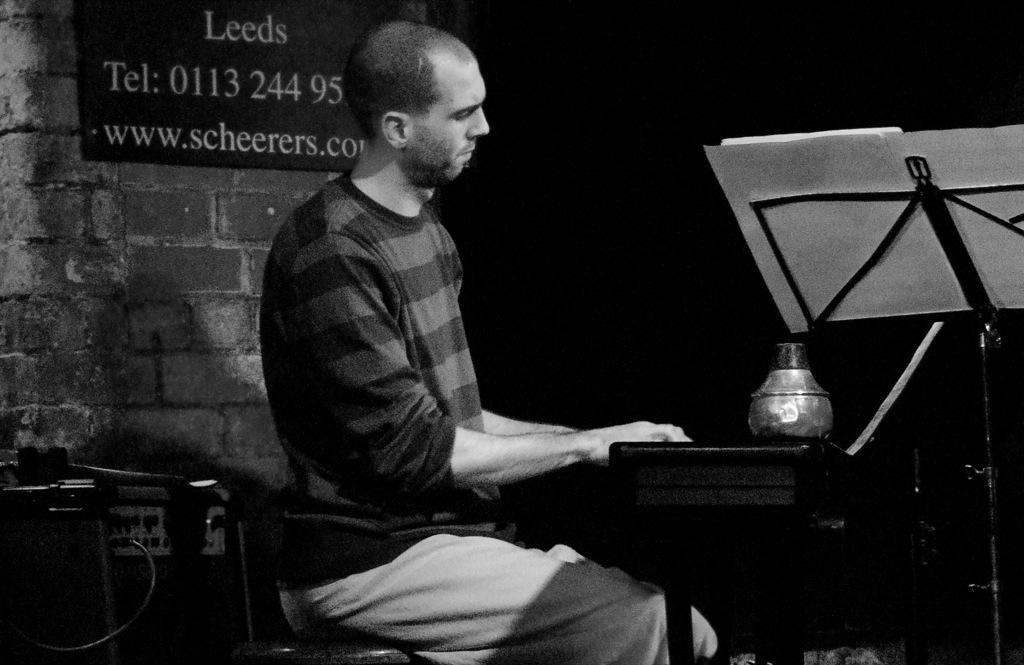Please provide a concise description of this image. In the center of the image we can see a man sitting and playing a piano. On the right there is a book placed on the stand. On the left there is a table. In the background we can see a wall and there is a board placed on the wall. 